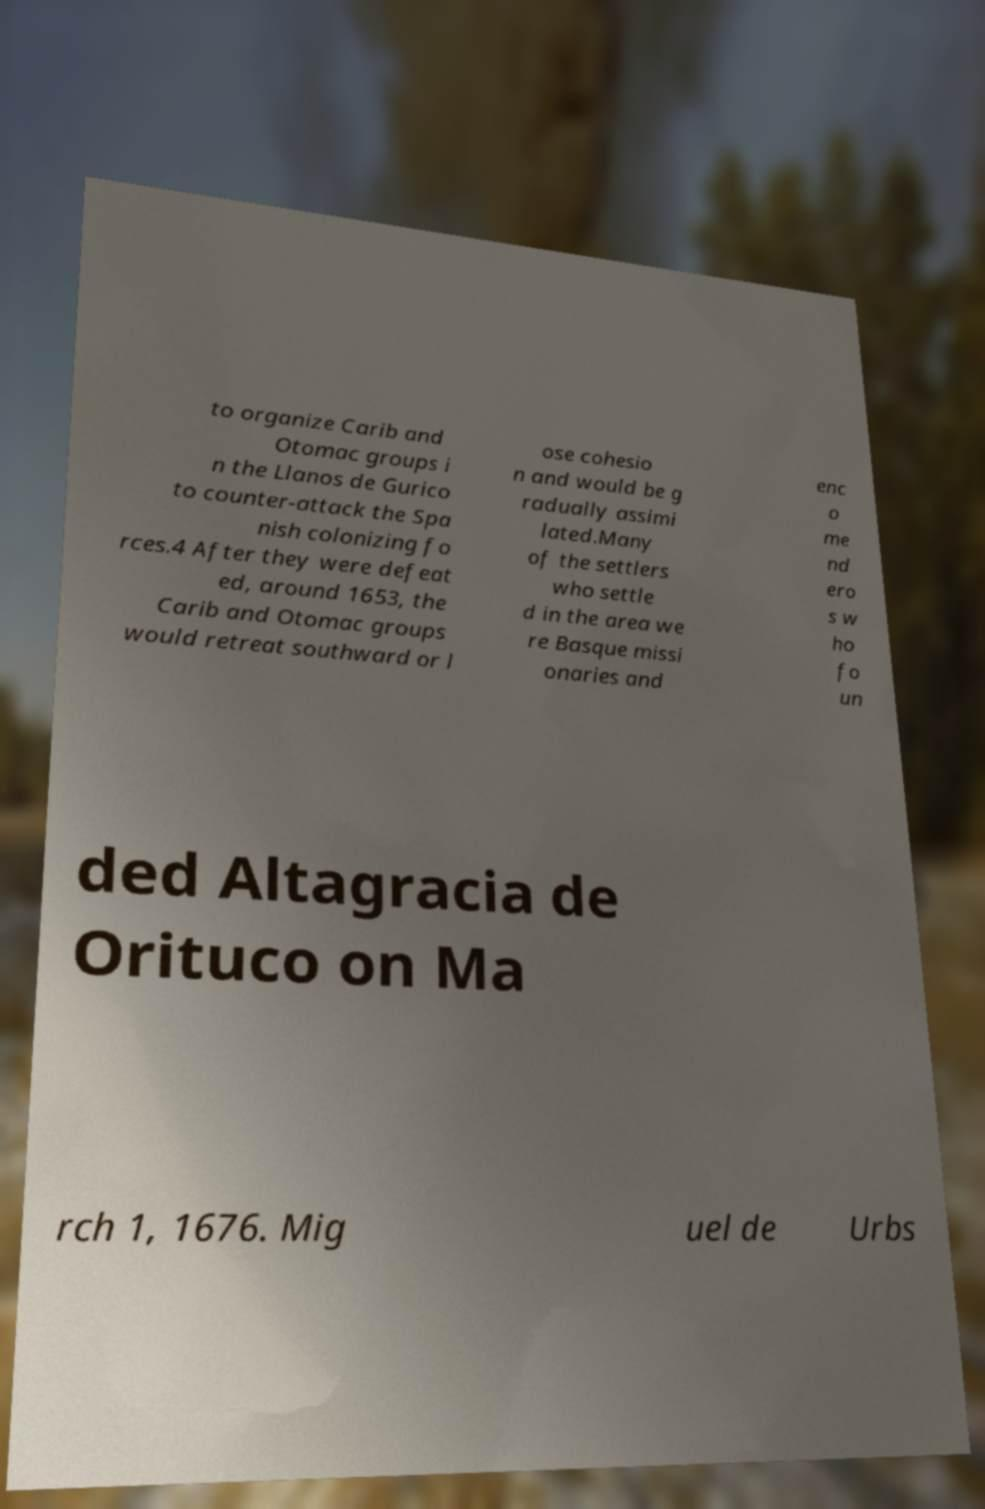Could you assist in decoding the text presented in this image and type it out clearly? to organize Carib and Otomac groups i n the Llanos de Gurico to counter-attack the Spa nish colonizing fo rces.4 After they were defeat ed, around 1653, the Carib and Otomac groups would retreat southward or l ose cohesio n and would be g radually assimi lated.Many of the settlers who settle d in the area we re Basque missi onaries and enc o me nd ero s w ho fo un ded Altagracia de Orituco on Ma rch 1, 1676. Mig uel de Urbs 